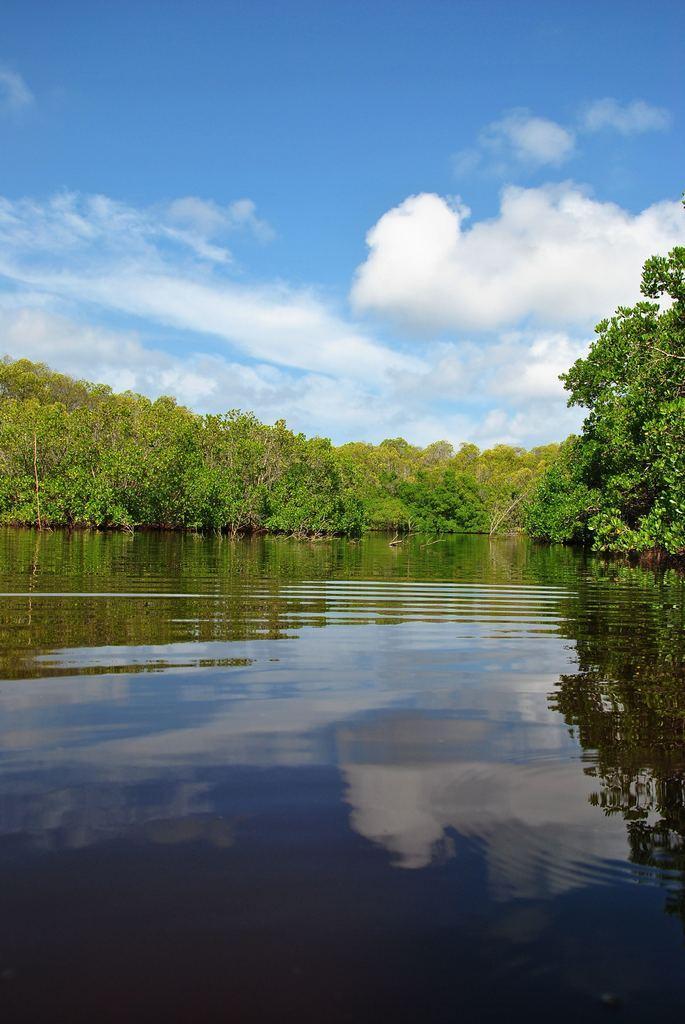How would you summarize this image in a sentence or two? In the foreground of the image we can see water. In the background, we can see a group of trees and a cloudy sky. 